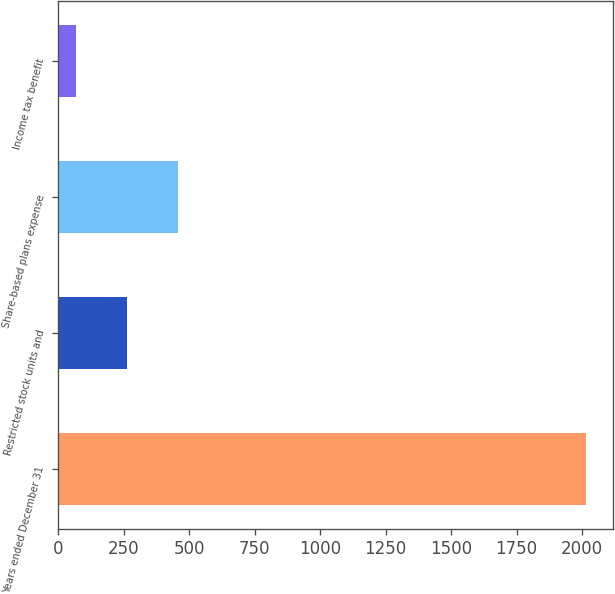Convert chart. <chart><loc_0><loc_0><loc_500><loc_500><bar_chart><fcel>Years ended December 31<fcel>Restricted stock units and<fcel>Share-based plans expense<fcel>Income tax benefit<nl><fcel>2016<fcel>263.7<fcel>458.4<fcel>69<nl></chart> 